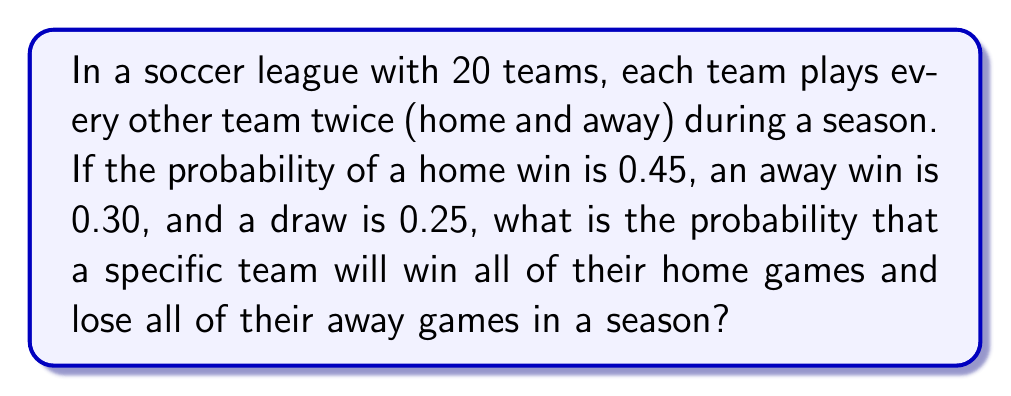Teach me how to tackle this problem. Let's approach this step-by-step:

1) First, we need to calculate how many games a team plays in a season:
   - Each team plays every other team twice (home and away)
   - There are 19 other teams
   - So, each team plays $19 \times 2 = 38$ games in total
   - Half of these (19) are home games, and half (19) are away games

2) The probability of winning a home game is given as 0.45

3) The probability of losing an away game is $1 - 0.30 - 0.25 = 0.45$ (since the probability of winning or drawing must be subtracted from 1)

4) For this scenario to occur, a team needs to:
   - Win all 19 home games AND
   - Lose all 19 away games

5) The probability of independent events occurring together is the product of their individual probabilities

6) So, the probability is:

   $$ P(\text{all home wins and all away losses}) = (0.45)^{19} \times (0.45)^{19} $$

7) This can be simplified to:

   $$ P(\text{all home wins and all away losses}) = (0.45)^{38} $$

8) Using a calculator (as this is a very small number):

   $$ (0.45)^{38} \approx 2.2052 \times 10^{-12} $$
Answer: $2.2052 \times 10^{-12}$ (or approximately 0.0000000000022052) 